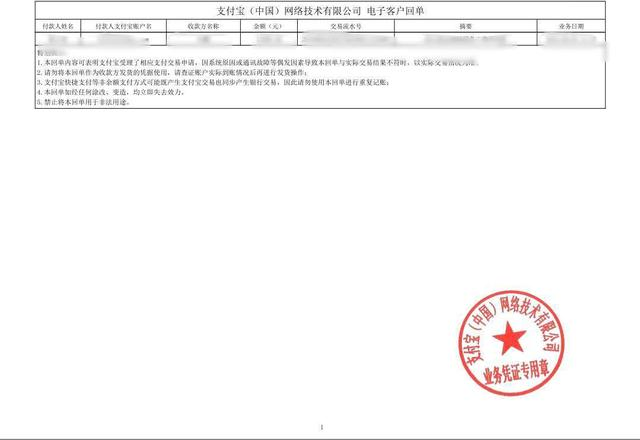识别图片中圆形印章中的文本 这张图片中包含了一个机构或单位的公章。公章右侧有一个圆形红色印章,可以看到其上有一颗五角星以及一些中文文字。这个印章似乎是一个行政机构或单位的印章,用于证明文件的权威性。不过我无法确定这个印章属于哪个具体的组织机构,因为我无法从图像中了解到更多的上下文信息。请您如果有任何进一步的问题,我很乐意为您提供更多的帮助。 